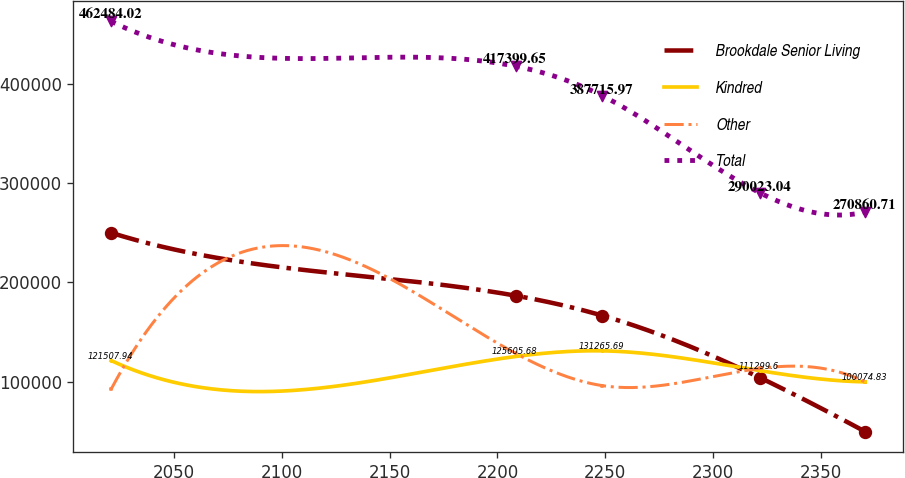<chart> <loc_0><loc_0><loc_500><loc_500><line_chart><ecel><fcel>Brookdale Senior Living<fcel>Kindred<fcel>Other<fcel>Total<nl><fcel>2020.68<fcel>249969<fcel>121508<fcel>92701.1<fcel>462484<nl><fcel>2208.48<fcel>186730<fcel>125606<fcel>128671<fcel>417400<nl><fcel>2248.66<fcel>166733<fcel>131266<fcel>96298.1<fcel>387716<nl><fcel>2321.93<fcel>104202<fcel>111300<fcel>113596<fcel>290023<nl><fcel>2370.7<fcel>50003.4<fcel>100075<fcel>99895.1<fcel>270861<nl></chart> 